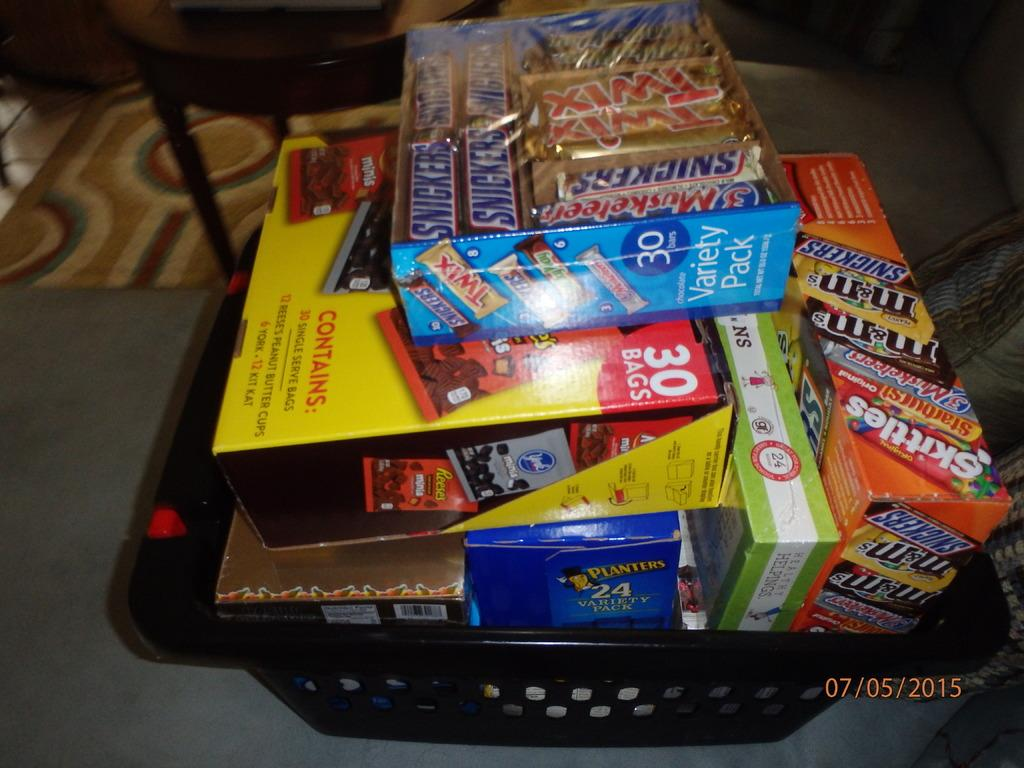<image>
Present a compact description of the photo's key features. A lot of candy in a basket, on top are some Snickers bars. 